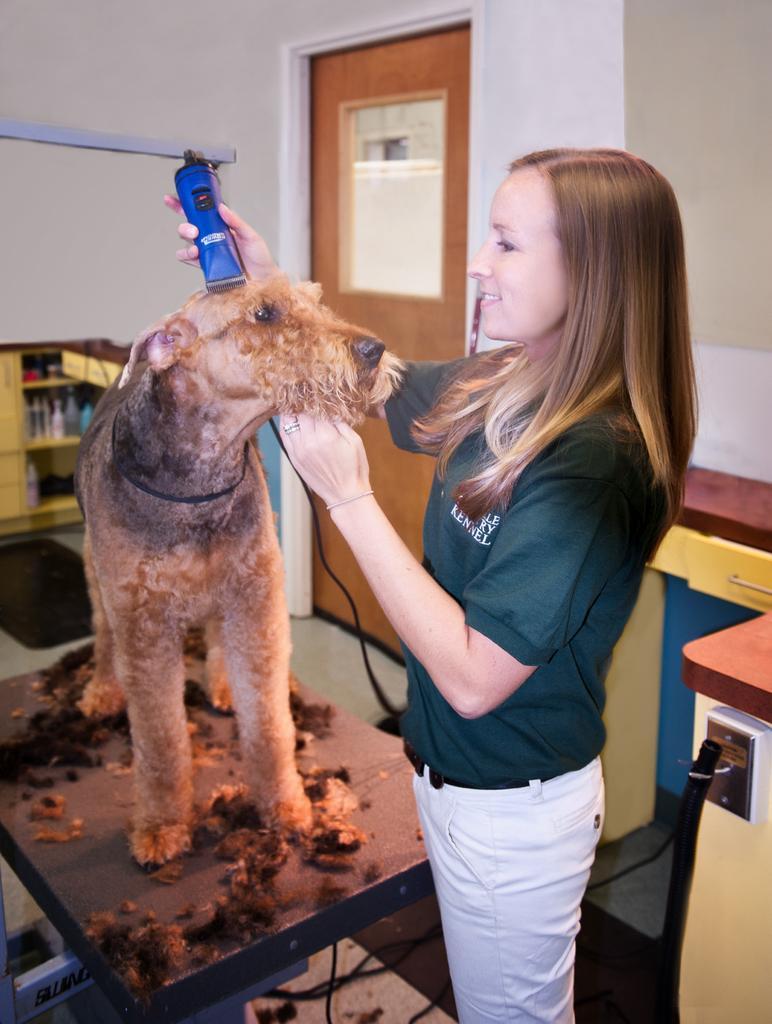In one or two sentences, can you explain what this image depicts? Here we can see a woman is standing on the floor and holding a dog in her hand ,it is on the table, and at back there is a door, and here is the wall. 